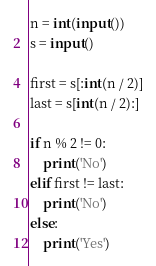Convert code to text. <code><loc_0><loc_0><loc_500><loc_500><_Python_>n = int(input())
s = input()

first = s[:int(n / 2)]
last = s[int(n / 2):]

if n % 2 != 0:
    print('No')
elif first != last:
    print('No')
else:
    print('Yes')</code> 